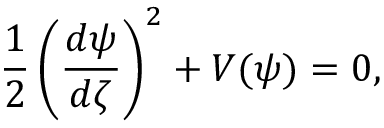<formula> <loc_0><loc_0><loc_500><loc_500>\frac { 1 } { 2 } \left ( \frac { d \psi } { d \zeta } \right ) ^ { 2 } + V ( \psi ) = 0 ,</formula> 